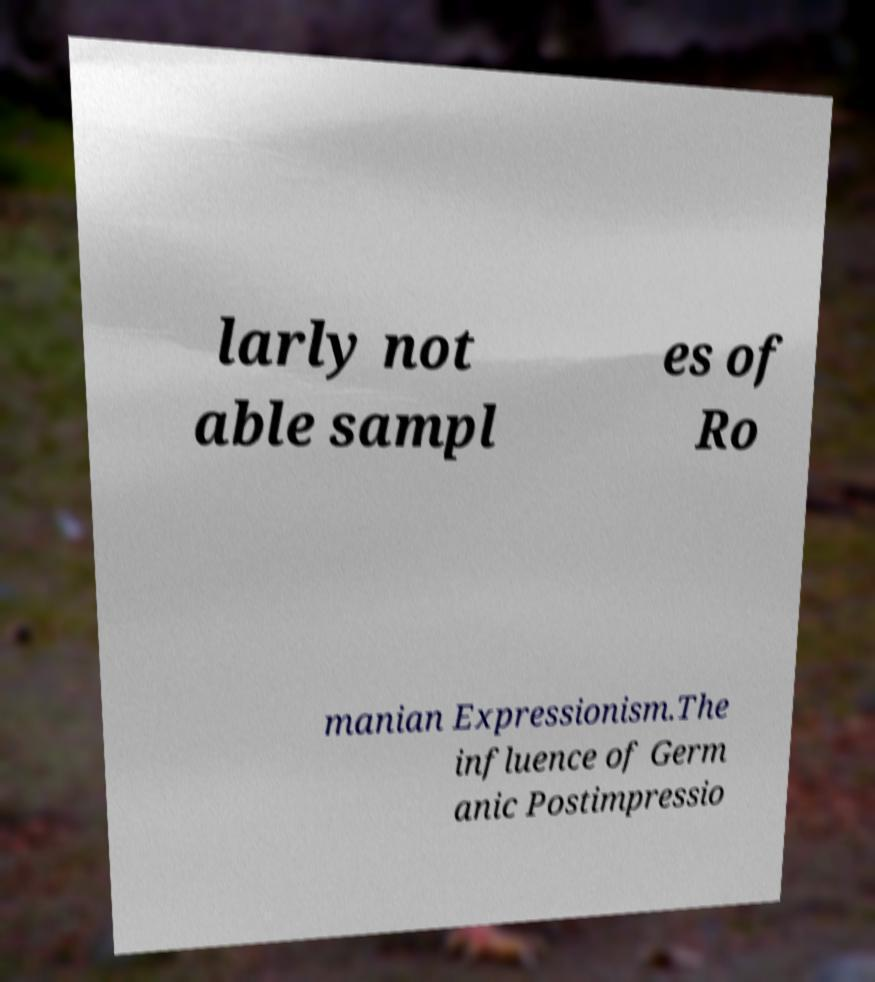Please read and relay the text visible in this image. What does it say? larly not able sampl es of Ro manian Expressionism.The influence of Germ anic Postimpressio 